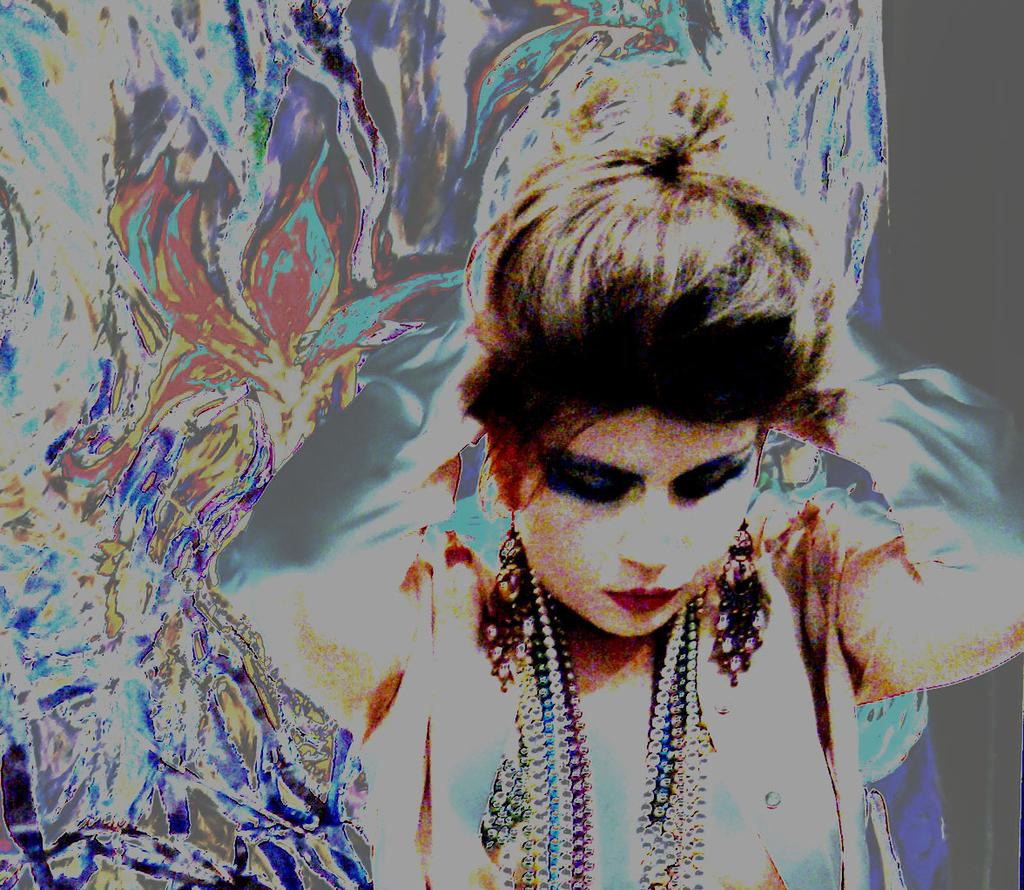What type of image is being described? The image is graphical in nature. Can you describe the main subject in the image? There is a woman in the front of the image. How many jellyfish are swimming in the background of the image? There are no jellyfish present in the image, as it is a graphical image featuring a woman in the front. 